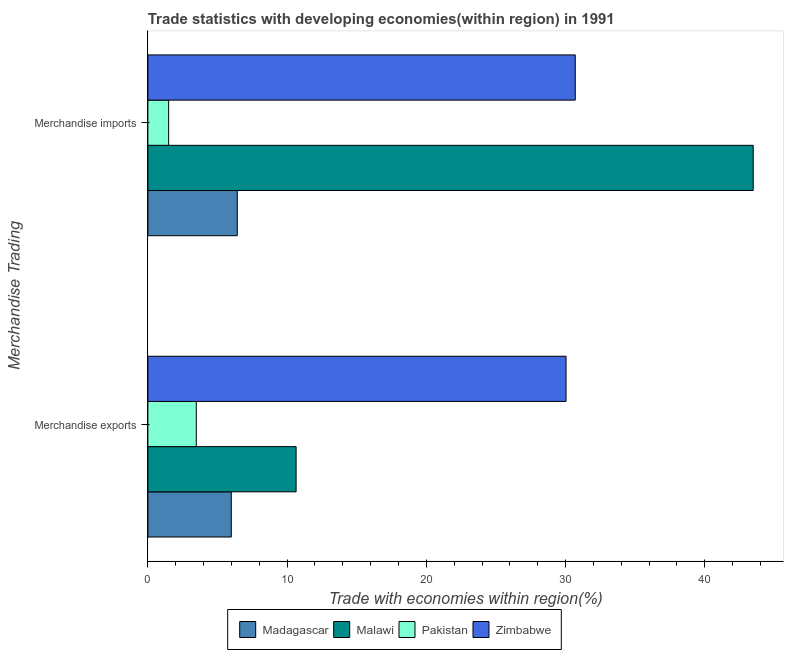Are the number of bars per tick equal to the number of legend labels?
Your answer should be compact. Yes. Are the number of bars on each tick of the Y-axis equal?
Offer a very short reply. Yes. How many bars are there on the 2nd tick from the bottom?
Offer a very short reply. 4. What is the merchandise imports in Malawi?
Provide a succinct answer. 43.48. Across all countries, what is the maximum merchandise imports?
Give a very brief answer. 43.48. Across all countries, what is the minimum merchandise exports?
Your answer should be compact. 3.48. In which country was the merchandise exports maximum?
Keep it short and to the point. Zimbabwe. In which country was the merchandise exports minimum?
Make the answer very short. Pakistan. What is the total merchandise imports in the graph?
Make the answer very short. 82.09. What is the difference between the merchandise imports in Pakistan and that in Malawi?
Keep it short and to the point. -41.99. What is the difference between the merchandise imports in Madagascar and the merchandise exports in Zimbabwe?
Provide a short and direct response. -23.61. What is the average merchandise exports per country?
Offer a terse response. 12.54. What is the difference between the merchandise exports and merchandise imports in Madagascar?
Offer a terse response. -0.43. In how many countries, is the merchandise imports greater than 8 %?
Offer a terse response. 2. What is the ratio of the merchandise exports in Madagascar to that in Malawi?
Make the answer very short. 0.56. What does the 2nd bar from the top in Merchandise imports represents?
Make the answer very short. Pakistan. How many countries are there in the graph?
Keep it short and to the point. 4. Are the values on the major ticks of X-axis written in scientific E-notation?
Your answer should be very brief. No. Does the graph contain grids?
Offer a terse response. No. How many legend labels are there?
Offer a very short reply. 4. What is the title of the graph?
Provide a succinct answer. Trade statistics with developing economies(within region) in 1991. Does "Burundi" appear as one of the legend labels in the graph?
Provide a succinct answer. No. What is the label or title of the X-axis?
Give a very brief answer. Trade with economies within region(%). What is the label or title of the Y-axis?
Keep it short and to the point. Merchandise Trading. What is the Trade with economies within region(%) in Madagascar in Merchandise exports?
Provide a succinct answer. 5.99. What is the Trade with economies within region(%) in Malawi in Merchandise exports?
Offer a very short reply. 10.65. What is the Trade with economies within region(%) in Pakistan in Merchandise exports?
Your answer should be very brief. 3.48. What is the Trade with economies within region(%) in Zimbabwe in Merchandise exports?
Make the answer very short. 30.03. What is the Trade with economies within region(%) in Madagascar in Merchandise imports?
Provide a succinct answer. 6.42. What is the Trade with economies within region(%) in Malawi in Merchandise imports?
Your answer should be compact. 43.48. What is the Trade with economies within region(%) in Pakistan in Merchandise imports?
Your answer should be very brief. 1.49. What is the Trade with economies within region(%) of Zimbabwe in Merchandise imports?
Your answer should be compact. 30.7. Across all Merchandise Trading, what is the maximum Trade with economies within region(%) of Madagascar?
Make the answer very short. 6.42. Across all Merchandise Trading, what is the maximum Trade with economies within region(%) of Malawi?
Offer a terse response. 43.48. Across all Merchandise Trading, what is the maximum Trade with economies within region(%) in Pakistan?
Your response must be concise. 3.48. Across all Merchandise Trading, what is the maximum Trade with economies within region(%) in Zimbabwe?
Provide a succinct answer. 30.7. Across all Merchandise Trading, what is the minimum Trade with economies within region(%) of Madagascar?
Your response must be concise. 5.99. Across all Merchandise Trading, what is the minimum Trade with economies within region(%) in Malawi?
Keep it short and to the point. 10.65. Across all Merchandise Trading, what is the minimum Trade with economies within region(%) in Pakistan?
Make the answer very short. 1.49. Across all Merchandise Trading, what is the minimum Trade with economies within region(%) of Zimbabwe?
Ensure brevity in your answer.  30.03. What is the total Trade with economies within region(%) of Madagascar in the graph?
Your answer should be very brief. 12.41. What is the total Trade with economies within region(%) of Malawi in the graph?
Ensure brevity in your answer.  54.13. What is the total Trade with economies within region(%) of Pakistan in the graph?
Provide a succinct answer. 4.97. What is the total Trade with economies within region(%) in Zimbabwe in the graph?
Offer a terse response. 60.73. What is the difference between the Trade with economies within region(%) of Madagascar in Merchandise exports and that in Merchandise imports?
Offer a terse response. -0.43. What is the difference between the Trade with economies within region(%) in Malawi in Merchandise exports and that in Merchandise imports?
Make the answer very short. -32.83. What is the difference between the Trade with economies within region(%) in Pakistan in Merchandise exports and that in Merchandise imports?
Your answer should be very brief. 1.99. What is the difference between the Trade with economies within region(%) of Zimbabwe in Merchandise exports and that in Merchandise imports?
Provide a succinct answer. -0.66. What is the difference between the Trade with economies within region(%) of Madagascar in Merchandise exports and the Trade with economies within region(%) of Malawi in Merchandise imports?
Your answer should be compact. -37.49. What is the difference between the Trade with economies within region(%) of Madagascar in Merchandise exports and the Trade with economies within region(%) of Pakistan in Merchandise imports?
Your answer should be very brief. 4.5. What is the difference between the Trade with economies within region(%) in Madagascar in Merchandise exports and the Trade with economies within region(%) in Zimbabwe in Merchandise imports?
Make the answer very short. -24.7. What is the difference between the Trade with economies within region(%) of Malawi in Merchandise exports and the Trade with economies within region(%) of Pakistan in Merchandise imports?
Your answer should be compact. 9.16. What is the difference between the Trade with economies within region(%) of Malawi in Merchandise exports and the Trade with economies within region(%) of Zimbabwe in Merchandise imports?
Your answer should be compact. -20.05. What is the difference between the Trade with economies within region(%) of Pakistan in Merchandise exports and the Trade with economies within region(%) of Zimbabwe in Merchandise imports?
Keep it short and to the point. -27.22. What is the average Trade with economies within region(%) in Madagascar per Merchandise Trading?
Provide a succinct answer. 6.21. What is the average Trade with economies within region(%) of Malawi per Merchandise Trading?
Provide a succinct answer. 27.06. What is the average Trade with economies within region(%) of Pakistan per Merchandise Trading?
Keep it short and to the point. 2.48. What is the average Trade with economies within region(%) in Zimbabwe per Merchandise Trading?
Your answer should be very brief. 30.37. What is the difference between the Trade with economies within region(%) of Madagascar and Trade with economies within region(%) of Malawi in Merchandise exports?
Make the answer very short. -4.66. What is the difference between the Trade with economies within region(%) in Madagascar and Trade with economies within region(%) in Pakistan in Merchandise exports?
Your answer should be very brief. 2.51. What is the difference between the Trade with economies within region(%) of Madagascar and Trade with economies within region(%) of Zimbabwe in Merchandise exports?
Offer a terse response. -24.04. What is the difference between the Trade with economies within region(%) of Malawi and Trade with economies within region(%) of Pakistan in Merchandise exports?
Offer a very short reply. 7.17. What is the difference between the Trade with economies within region(%) of Malawi and Trade with economies within region(%) of Zimbabwe in Merchandise exports?
Your answer should be compact. -19.39. What is the difference between the Trade with economies within region(%) of Pakistan and Trade with economies within region(%) of Zimbabwe in Merchandise exports?
Your answer should be compact. -26.56. What is the difference between the Trade with economies within region(%) of Madagascar and Trade with economies within region(%) of Malawi in Merchandise imports?
Offer a terse response. -37.06. What is the difference between the Trade with economies within region(%) of Madagascar and Trade with economies within region(%) of Pakistan in Merchandise imports?
Ensure brevity in your answer.  4.93. What is the difference between the Trade with economies within region(%) in Madagascar and Trade with economies within region(%) in Zimbabwe in Merchandise imports?
Your response must be concise. -24.27. What is the difference between the Trade with economies within region(%) of Malawi and Trade with economies within region(%) of Pakistan in Merchandise imports?
Keep it short and to the point. 41.99. What is the difference between the Trade with economies within region(%) of Malawi and Trade with economies within region(%) of Zimbabwe in Merchandise imports?
Provide a succinct answer. 12.78. What is the difference between the Trade with economies within region(%) of Pakistan and Trade with economies within region(%) of Zimbabwe in Merchandise imports?
Your answer should be compact. -29.2. What is the ratio of the Trade with economies within region(%) in Madagascar in Merchandise exports to that in Merchandise imports?
Your answer should be compact. 0.93. What is the ratio of the Trade with economies within region(%) of Malawi in Merchandise exports to that in Merchandise imports?
Keep it short and to the point. 0.24. What is the ratio of the Trade with economies within region(%) in Pakistan in Merchandise exports to that in Merchandise imports?
Keep it short and to the point. 2.33. What is the ratio of the Trade with economies within region(%) in Zimbabwe in Merchandise exports to that in Merchandise imports?
Your answer should be very brief. 0.98. What is the difference between the highest and the second highest Trade with economies within region(%) of Madagascar?
Provide a succinct answer. 0.43. What is the difference between the highest and the second highest Trade with economies within region(%) of Malawi?
Ensure brevity in your answer.  32.83. What is the difference between the highest and the second highest Trade with economies within region(%) of Pakistan?
Make the answer very short. 1.99. What is the difference between the highest and the second highest Trade with economies within region(%) of Zimbabwe?
Your answer should be compact. 0.66. What is the difference between the highest and the lowest Trade with economies within region(%) in Madagascar?
Ensure brevity in your answer.  0.43. What is the difference between the highest and the lowest Trade with economies within region(%) in Malawi?
Offer a terse response. 32.83. What is the difference between the highest and the lowest Trade with economies within region(%) in Pakistan?
Keep it short and to the point. 1.99. What is the difference between the highest and the lowest Trade with economies within region(%) of Zimbabwe?
Your response must be concise. 0.66. 